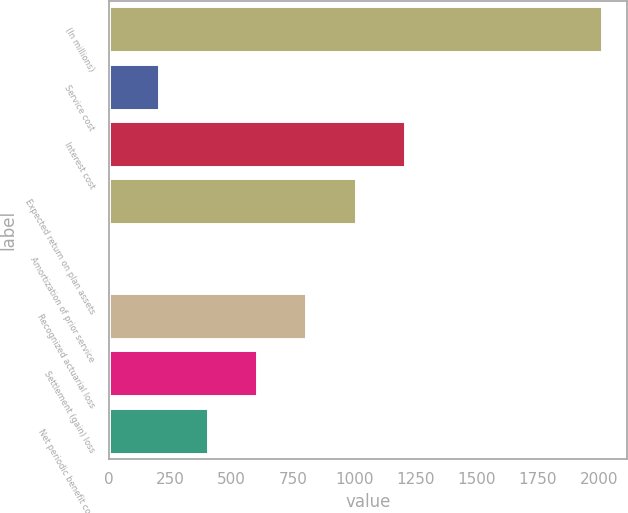Convert chart. <chart><loc_0><loc_0><loc_500><loc_500><bar_chart><fcel>(In millions)<fcel>Service cost<fcel>Interest cost<fcel>Expected return on plan assets<fcel>Amortization of prior service<fcel>Recognized actuarial loss<fcel>Settlement (gain) loss<fcel>Net periodic benefit cost<nl><fcel>2011<fcel>201.49<fcel>1206.79<fcel>1005.73<fcel>0.43<fcel>804.67<fcel>603.61<fcel>402.55<nl></chart> 